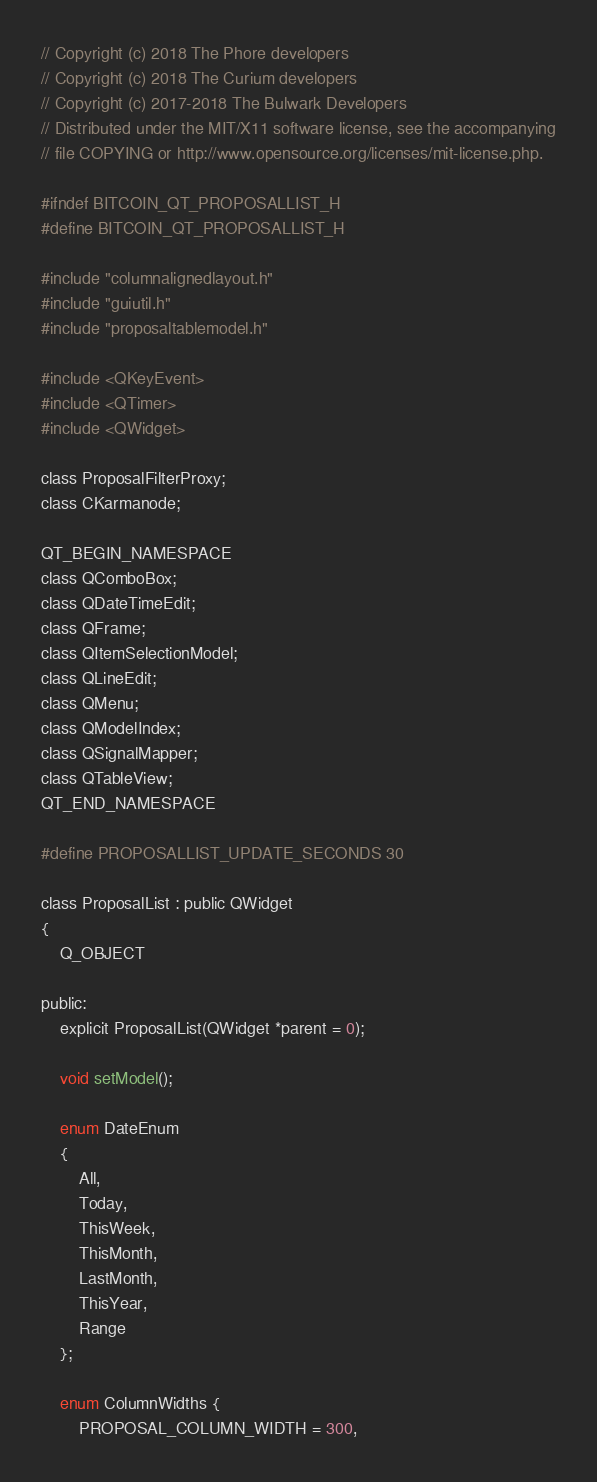<code> <loc_0><loc_0><loc_500><loc_500><_C_>// Copyright (c) 2018 The Phore developers
// Copyright (c) 2018 The Curium developers
// Copyright (c) 2017-2018 The Bulwark Developers
// Distributed under the MIT/X11 software license, see the accompanying
// file COPYING or http://www.opensource.org/licenses/mit-license.php.

#ifndef BITCOIN_QT_PROPOSALLIST_H
#define BITCOIN_QT_PROPOSALLIST_H

#include "columnalignedlayout.h"
#include "guiutil.h"
#include "proposaltablemodel.h"

#include <QKeyEvent>
#include <QTimer>
#include <QWidget>

class ProposalFilterProxy;
class CKarmanode;

QT_BEGIN_NAMESPACE
class QComboBox;
class QDateTimeEdit;
class QFrame;
class QItemSelectionModel;
class QLineEdit;
class QMenu;
class QModelIndex;
class QSignalMapper;
class QTableView;
QT_END_NAMESPACE

#define PROPOSALLIST_UPDATE_SECONDS 30

class ProposalList : public QWidget
{
    Q_OBJECT

public:
    explicit ProposalList(QWidget *parent = 0);

    void setModel();

    enum DateEnum
    {
        All,
        Today,
        ThisWeek,
        ThisMonth,
        LastMonth,
        ThisYear,
        Range
    };

    enum ColumnWidths {
        PROPOSAL_COLUMN_WIDTH = 300,</code> 